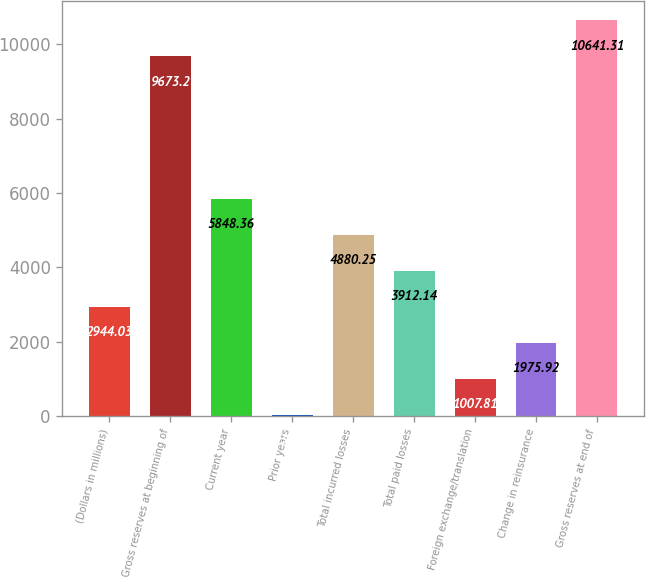Convert chart. <chart><loc_0><loc_0><loc_500><loc_500><bar_chart><fcel>(Dollars in millions)<fcel>Gross reserves at beginning of<fcel>Current year<fcel>Prior years<fcel>Total incurred losses<fcel>Total paid losses<fcel>Foreign exchange/translation<fcel>Change in reinsurance<fcel>Gross reserves at end of<nl><fcel>2944.03<fcel>9673.2<fcel>5848.36<fcel>39.7<fcel>4880.25<fcel>3912.14<fcel>1007.81<fcel>1975.92<fcel>10641.3<nl></chart> 